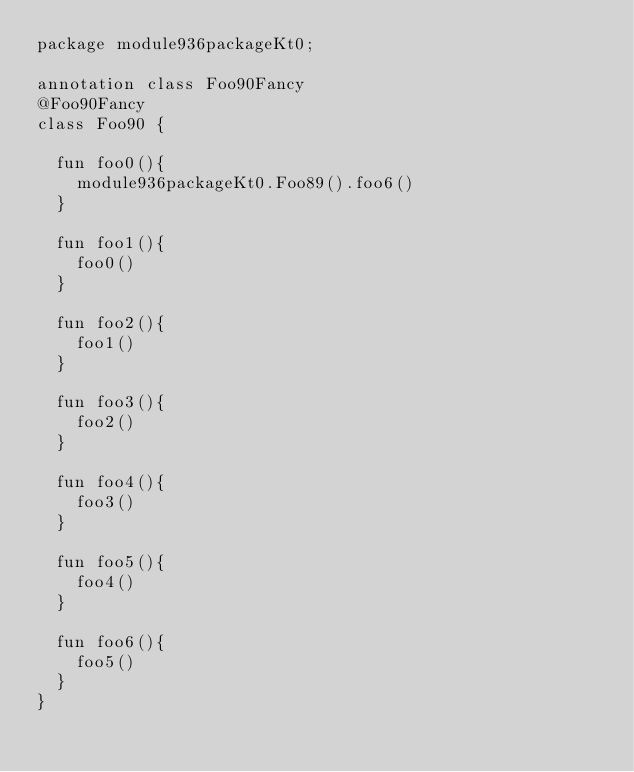<code> <loc_0><loc_0><loc_500><loc_500><_Kotlin_>package module936packageKt0;

annotation class Foo90Fancy
@Foo90Fancy
class Foo90 {

  fun foo0(){
    module936packageKt0.Foo89().foo6()
  }

  fun foo1(){
    foo0()
  }

  fun foo2(){
    foo1()
  }

  fun foo3(){
    foo2()
  }

  fun foo4(){
    foo3()
  }

  fun foo5(){
    foo4()
  }

  fun foo6(){
    foo5()
  }
}</code> 